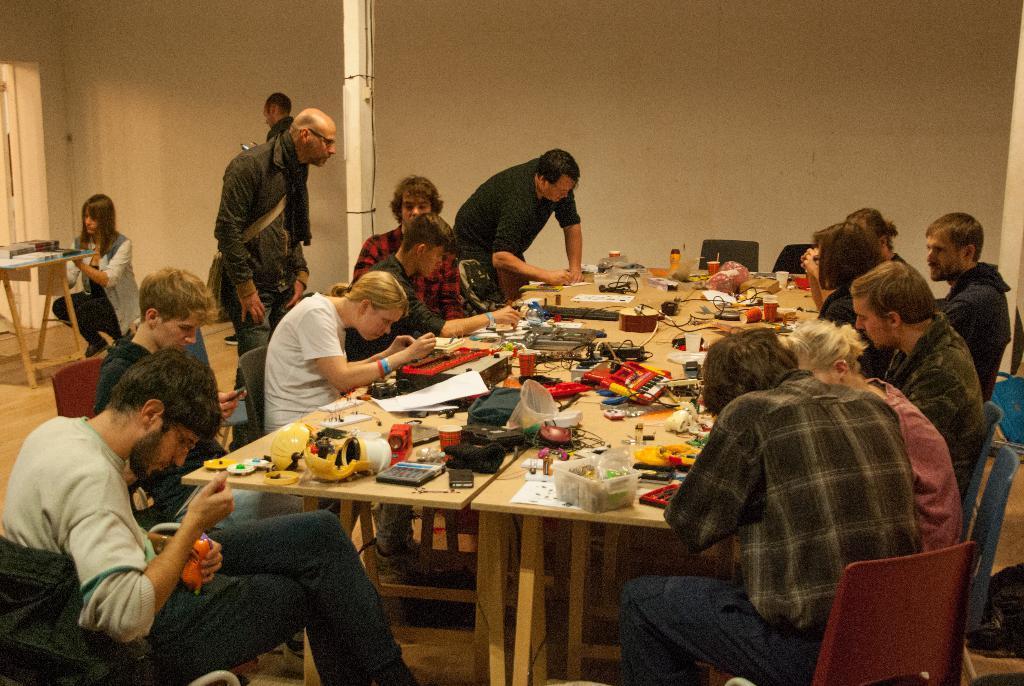In one or two sentences, can you explain what this image depicts? These persons are sitting on a chair. On this table there are things. These 2 persons are standing. 